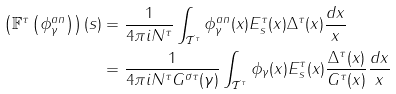<formula> <loc_0><loc_0><loc_500><loc_500>\left ( \mathbb { F } ^ { \tau } \left ( \phi _ { \gamma } ^ { a n } \right ) \right ) ( s ) & = \frac { 1 } { 4 \pi i N ^ { \tau } } \int _ { \mathcal { T } ^ { \tau } } \phi _ { \gamma } ^ { a n } ( x ) E _ { s } ^ { \tau } ( x ) \Delta ^ { \tau } ( x ) \frac { d x } { x } \\ & = \frac { 1 } { 4 \pi i N ^ { \tau } G ^ { \sigma \tau } ( \gamma ) } \int _ { \mathcal { T } ^ { \tau } } \phi _ { \gamma } ( x ) E _ { s } ^ { \tau } ( x ) \frac { \Delta ^ { \tau } ( x ) } { G ^ { \tau } ( x ) } \frac { d x } { x }</formula> 